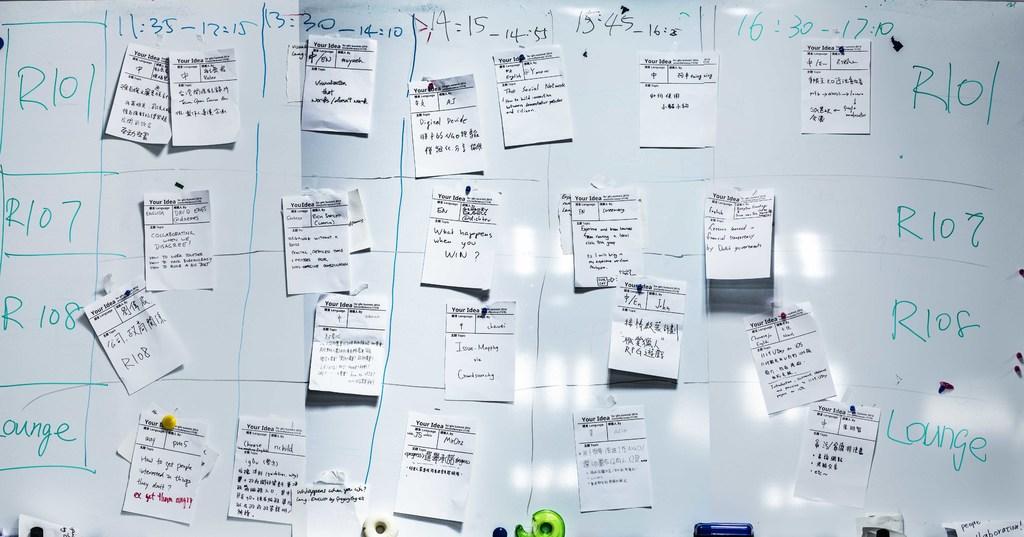What is the earliest time listed?
Your response must be concise. 11:35. 